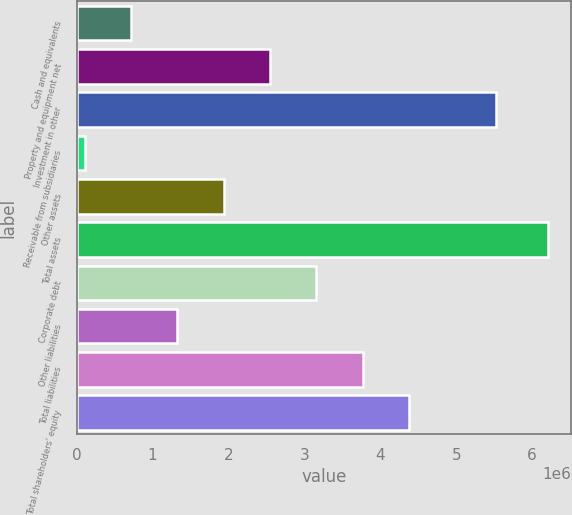Convert chart to OTSL. <chart><loc_0><loc_0><loc_500><loc_500><bar_chart><fcel>Cash and equivalents<fcel>Property and equipment net<fcel>Investment in other<fcel>Receivable from subsidiaries<fcel>Other assets<fcel>Total assets<fcel>Corporate debt<fcel>Other liabilities<fcel>Total liabilities<fcel>Total shareholders' equity<nl><fcel>717048<fcel>2.5471e+06<fcel>5.52901e+06<fcel>107031<fcel>1.93708e+06<fcel>6.2072e+06<fcel>3.15711e+06<fcel>1.32706e+06<fcel>3.76713e+06<fcel>4.37715e+06<nl></chart> 